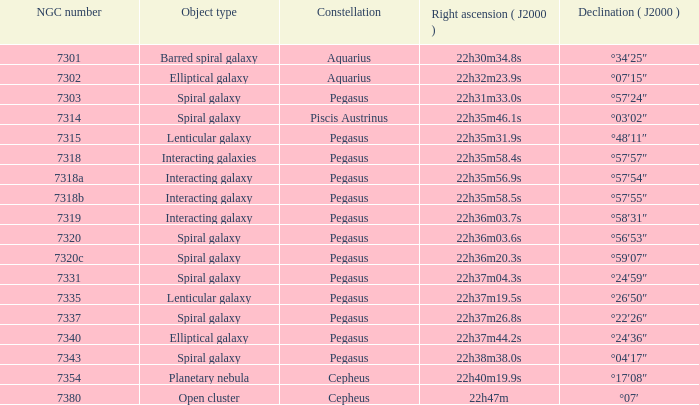What is the declination of the spiral galaxy pegasus containing 7337 ngc? °22′26″. 